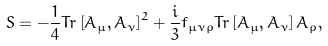Convert formula to latex. <formula><loc_0><loc_0><loc_500><loc_500>S = - \frac { 1 } { 4 } T r \left [ A _ { \mu } , A _ { \nu } \right ] ^ { 2 } + \frac { i } { 3 } f _ { \mu \nu \rho } T r \left [ A _ { \mu } , A _ { \nu } \right ] A _ { \rho } ,</formula> 